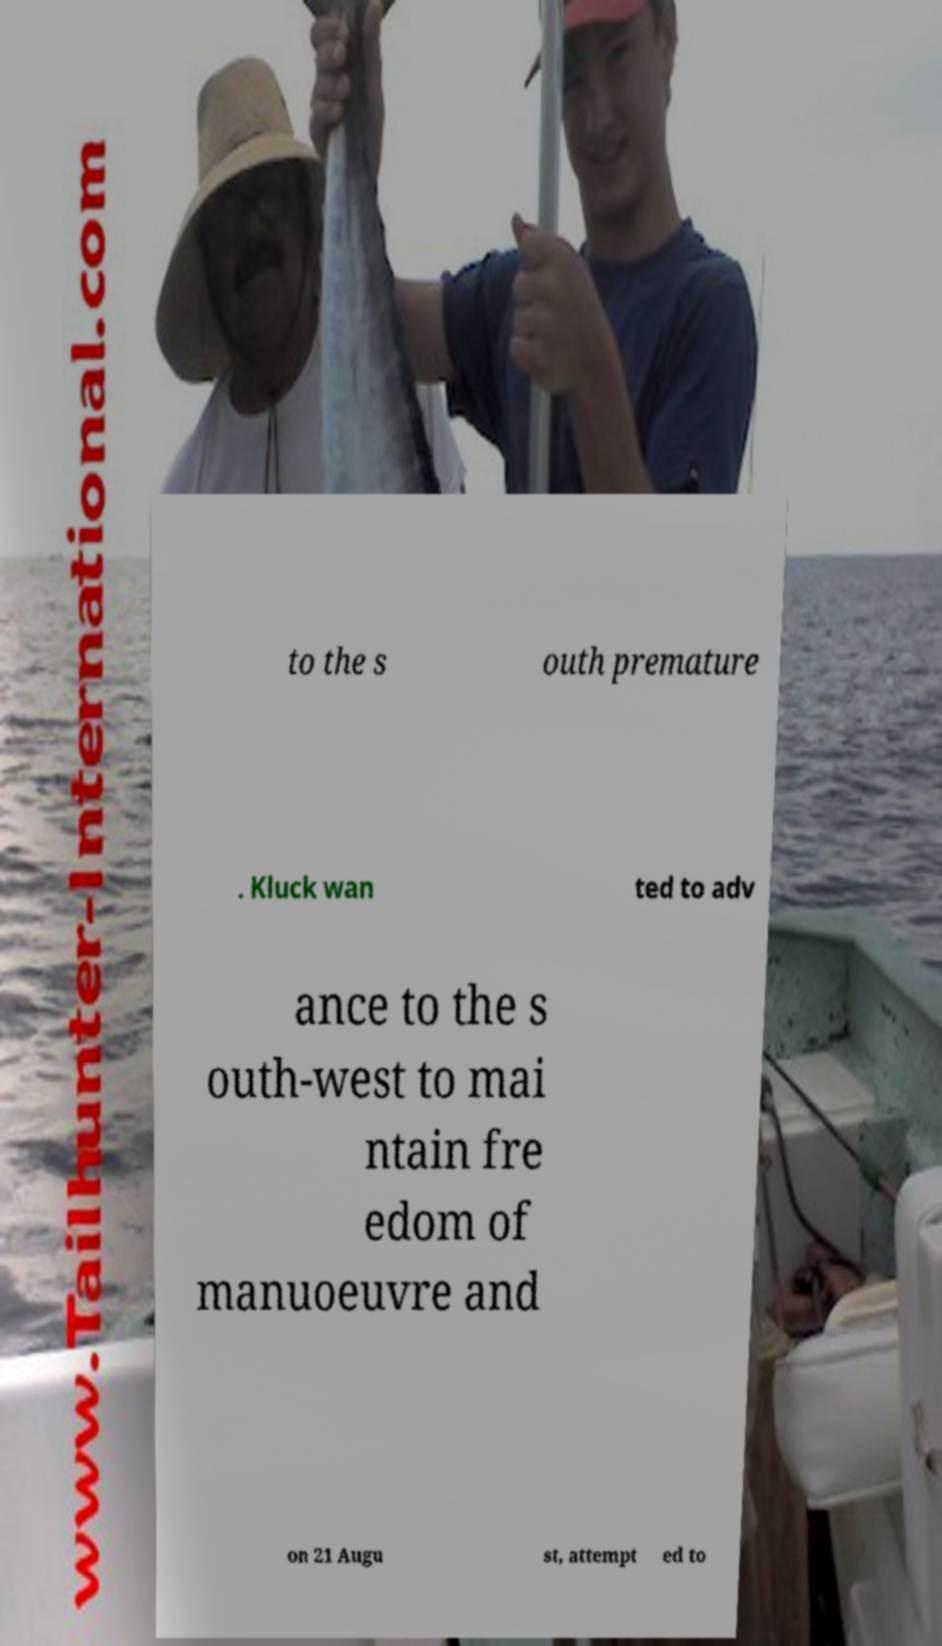Can you read and provide the text displayed in the image?This photo seems to have some interesting text. Can you extract and type it out for me? to the s outh premature . Kluck wan ted to adv ance to the s outh-west to mai ntain fre edom of manuoeuvre and on 21 Augu st, attempt ed to 